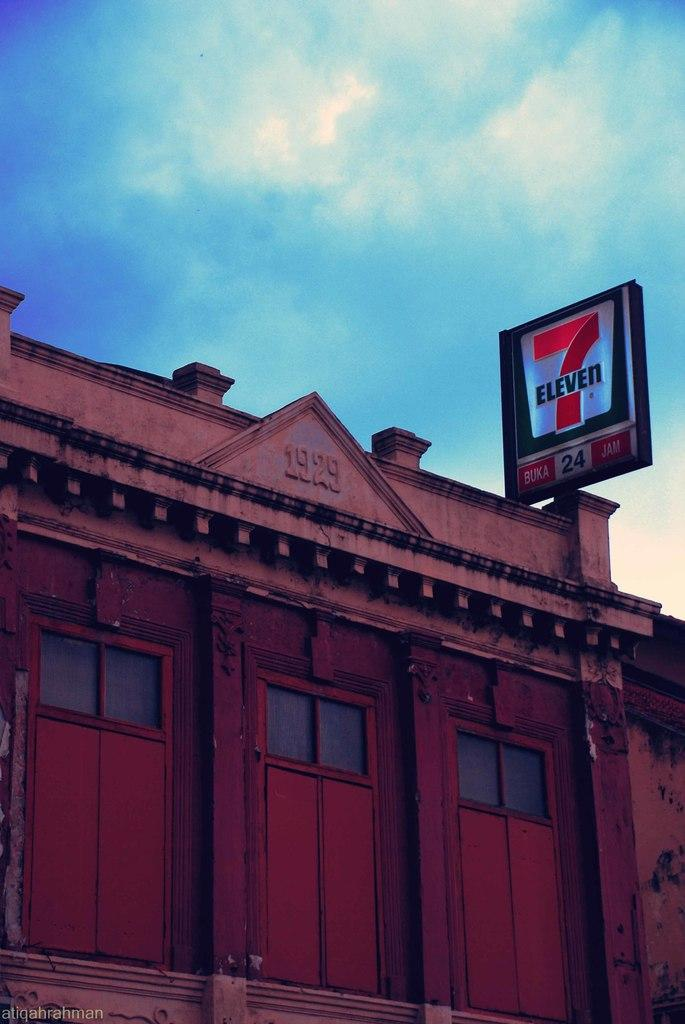What type of structure is present in the image? There is a building in the image. What can be seen on the right side of the image? There is a pole on the right side of the image. What is visible at the top of the image? The sky is visible at the top of the image. Can you describe the goat's experience during its journey in the image? There is no goat or journey present in the image. 